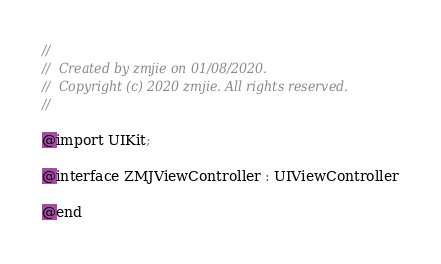<code> <loc_0><loc_0><loc_500><loc_500><_C_>//
//  Created by zmjie on 01/08/2020.
//  Copyright (c) 2020 zmjie. All rights reserved.
//

@import UIKit;

@interface ZMJViewController : UIViewController

@end
</code> 